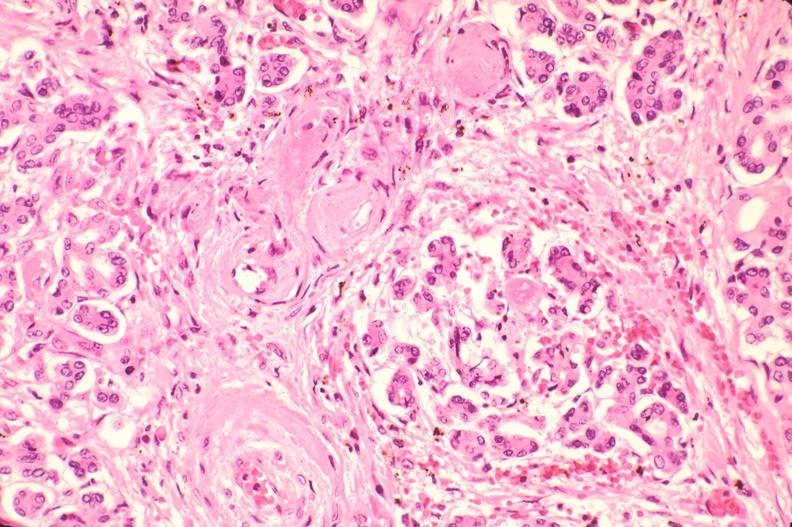what does this image show?
Answer the question using a single word or phrase. Pancreas 